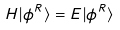<formula> <loc_0><loc_0><loc_500><loc_500>H | \phi ^ { R } \rangle = E | \phi ^ { R } \rangle</formula> 